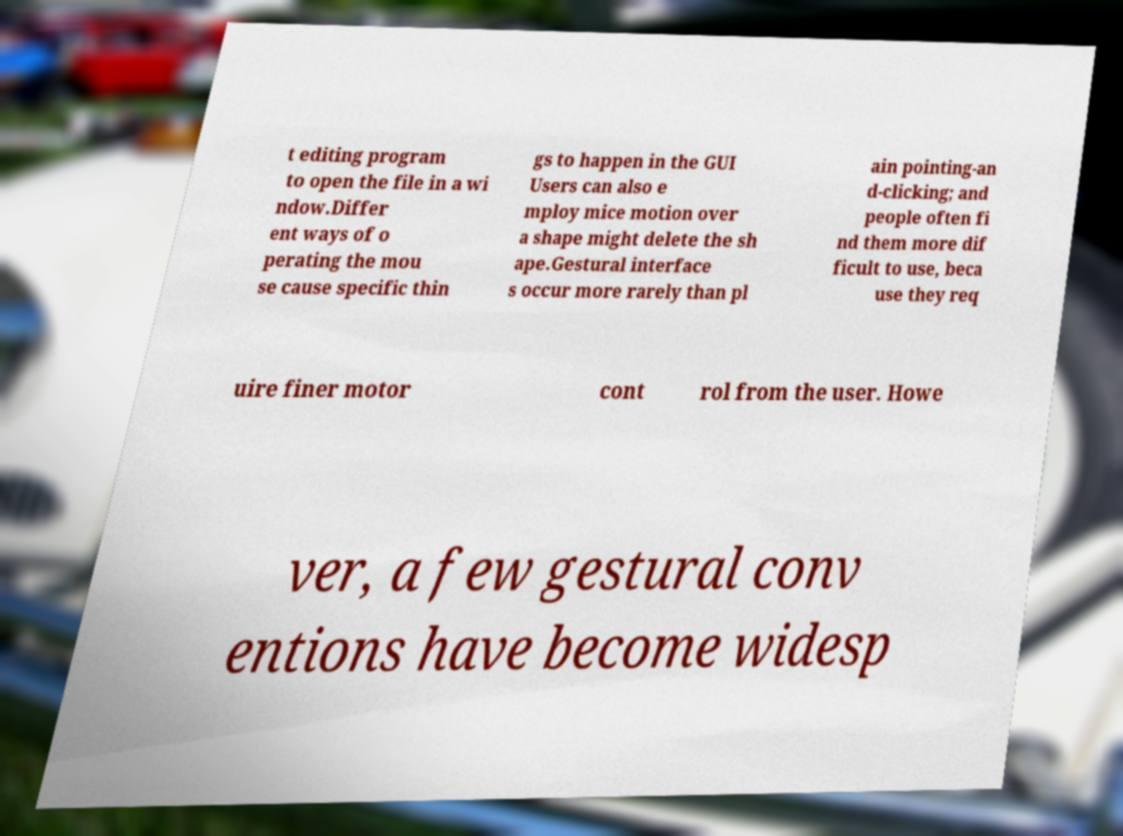Please identify and transcribe the text found in this image. t editing program to open the file in a wi ndow.Differ ent ways of o perating the mou se cause specific thin gs to happen in the GUI Users can also e mploy mice motion over a shape might delete the sh ape.Gestural interface s occur more rarely than pl ain pointing-an d-clicking; and people often fi nd them more dif ficult to use, beca use they req uire finer motor cont rol from the user. Howe ver, a few gestural conv entions have become widesp 